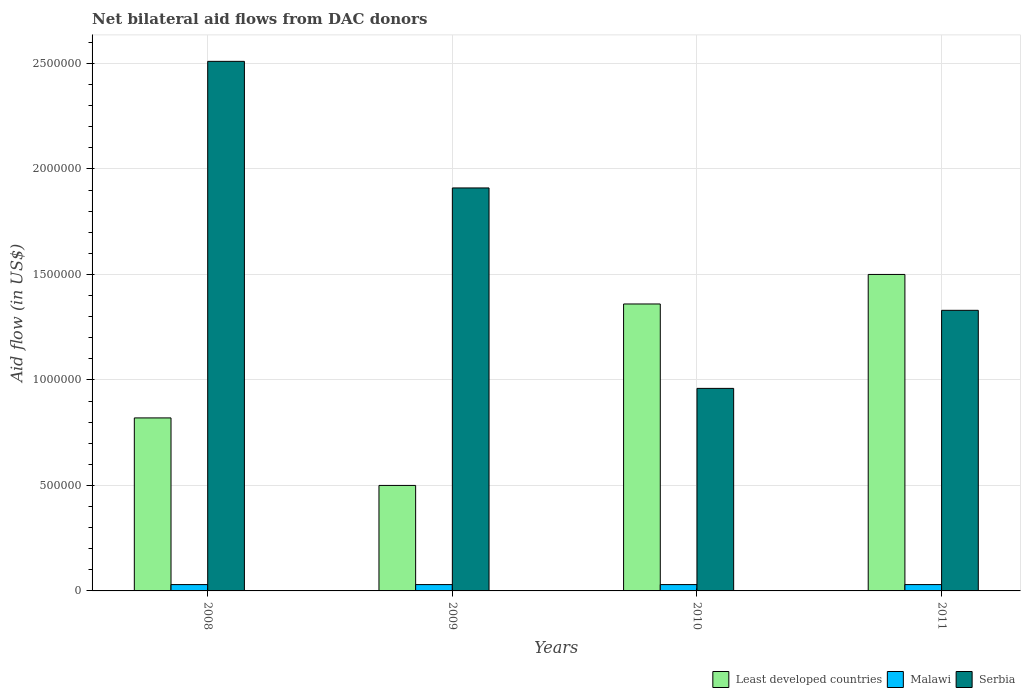How many groups of bars are there?
Provide a succinct answer. 4. Are the number of bars per tick equal to the number of legend labels?
Your answer should be very brief. Yes. How many bars are there on the 3rd tick from the left?
Offer a very short reply. 3. How many bars are there on the 4th tick from the right?
Your answer should be very brief. 3. What is the net bilateral aid flow in Least developed countries in 2009?
Your answer should be very brief. 5.00e+05. Across all years, what is the maximum net bilateral aid flow in Serbia?
Ensure brevity in your answer.  2.51e+06. Across all years, what is the minimum net bilateral aid flow in Serbia?
Make the answer very short. 9.60e+05. What is the total net bilateral aid flow in Serbia in the graph?
Offer a very short reply. 6.71e+06. What is the difference between the net bilateral aid flow in Least developed countries in 2008 and that in 2009?
Give a very brief answer. 3.20e+05. What is the difference between the net bilateral aid flow in Serbia in 2010 and the net bilateral aid flow in Least developed countries in 2009?
Keep it short and to the point. 4.60e+05. What is the average net bilateral aid flow in Serbia per year?
Your response must be concise. 1.68e+06. In the year 2010, what is the difference between the net bilateral aid flow in Malawi and net bilateral aid flow in Serbia?
Offer a terse response. -9.30e+05. In how many years, is the net bilateral aid flow in Serbia greater than 200000 US$?
Your response must be concise. 4. What is the ratio of the net bilateral aid flow in Least developed countries in 2009 to that in 2011?
Your answer should be compact. 0.33. What is the difference between the highest and the second highest net bilateral aid flow in Least developed countries?
Provide a succinct answer. 1.40e+05. What is the difference between the highest and the lowest net bilateral aid flow in Serbia?
Make the answer very short. 1.55e+06. Is the sum of the net bilateral aid flow in Malawi in 2008 and 2009 greater than the maximum net bilateral aid flow in Serbia across all years?
Offer a terse response. No. What does the 2nd bar from the left in 2011 represents?
Give a very brief answer. Malawi. What does the 3rd bar from the right in 2010 represents?
Provide a succinct answer. Least developed countries. How many bars are there?
Keep it short and to the point. 12. Are all the bars in the graph horizontal?
Offer a very short reply. No. What is the difference between two consecutive major ticks on the Y-axis?
Make the answer very short. 5.00e+05. Does the graph contain grids?
Your response must be concise. Yes. How many legend labels are there?
Your answer should be compact. 3. What is the title of the graph?
Offer a very short reply. Net bilateral aid flows from DAC donors. Does "Romania" appear as one of the legend labels in the graph?
Your answer should be very brief. No. What is the label or title of the Y-axis?
Offer a terse response. Aid flow (in US$). What is the Aid flow (in US$) in Least developed countries in 2008?
Ensure brevity in your answer.  8.20e+05. What is the Aid flow (in US$) of Malawi in 2008?
Keep it short and to the point. 3.00e+04. What is the Aid flow (in US$) in Serbia in 2008?
Provide a succinct answer. 2.51e+06. What is the Aid flow (in US$) in Least developed countries in 2009?
Your response must be concise. 5.00e+05. What is the Aid flow (in US$) in Serbia in 2009?
Offer a terse response. 1.91e+06. What is the Aid flow (in US$) of Least developed countries in 2010?
Your answer should be very brief. 1.36e+06. What is the Aid flow (in US$) in Malawi in 2010?
Offer a terse response. 3.00e+04. What is the Aid flow (in US$) in Serbia in 2010?
Provide a succinct answer. 9.60e+05. What is the Aid flow (in US$) of Least developed countries in 2011?
Provide a short and direct response. 1.50e+06. What is the Aid flow (in US$) in Serbia in 2011?
Provide a succinct answer. 1.33e+06. Across all years, what is the maximum Aid flow (in US$) in Least developed countries?
Your response must be concise. 1.50e+06. Across all years, what is the maximum Aid flow (in US$) in Serbia?
Make the answer very short. 2.51e+06. Across all years, what is the minimum Aid flow (in US$) in Least developed countries?
Offer a terse response. 5.00e+05. Across all years, what is the minimum Aid flow (in US$) of Malawi?
Give a very brief answer. 3.00e+04. Across all years, what is the minimum Aid flow (in US$) of Serbia?
Offer a terse response. 9.60e+05. What is the total Aid flow (in US$) of Least developed countries in the graph?
Your answer should be very brief. 4.18e+06. What is the total Aid flow (in US$) of Serbia in the graph?
Offer a very short reply. 6.71e+06. What is the difference between the Aid flow (in US$) of Least developed countries in 2008 and that in 2009?
Offer a very short reply. 3.20e+05. What is the difference between the Aid flow (in US$) of Serbia in 2008 and that in 2009?
Offer a very short reply. 6.00e+05. What is the difference between the Aid flow (in US$) in Least developed countries in 2008 and that in 2010?
Ensure brevity in your answer.  -5.40e+05. What is the difference between the Aid flow (in US$) in Serbia in 2008 and that in 2010?
Ensure brevity in your answer.  1.55e+06. What is the difference between the Aid flow (in US$) in Least developed countries in 2008 and that in 2011?
Offer a very short reply. -6.80e+05. What is the difference between the Aid flow (in US$) of Malawi in 2008 and that in 2011?
Keep it short and to the point. 0. What is the difference between the Aid flow (in US$) in Serbia in 2008 and that in 2011?
Give a very brief answer. 1.18e+06. What is the difference between the Aid flow (in US$) of Least developed countries in 2009 and that in 2010?
Provide a short and direct response. -8.60e+05. What is the difference between the Aid flow (in US$) in Serbia in 2009 and that in 2010?
Provide a short and direct response. 9.50e+05. What is the difference between the Aid flow (in US$) in Least developed countries in 2009 and that in 2011?
Make the answer very short. -1.00e+06. What is the difference between the Aid flow (in US$) of Malawi in 2009 and that in 2011?
Ensure brevity in your answer.  0. What is the difference between the Aid flow (in US$) in Serbia in 2009 and that in 2011?
Keep it short and to the point. 5.80e+05. What is the difference between the Aid flow (in US$) in Least developed countries in 2010 and that in 2011?
Provide a short and direct response. -1.40e+05. What is the difference between the Aid flow (in US$) in Malawi in 2010 and that in 2011?
Your answer should be very brief. 0. What is the difference between the Aid flow (in US$) of Serbia in 2010 and that in 2011?
Your response must be concise. -3.70e+05. What is the difference between the Aid flow (in US$) of Least developed countries in 2008 and the Aid flow (in US$) of Malawi in 2009?
Ensure brevity in your answer.  7.90e+05. What is the difference between the Aid flow (in US$) of Least developed countries in 2008 and the Aid flow (in US$) of Serbia in 2009?
Provide a succinct answer. -1.09e+06. What is the difference between the Aid flow (in US$) of Malawi in 2008 and the Aid flow (in US$) of Serbia in 2009?
Keep it short and to the point. -1.88e+06. What is the difference between the Aid flow (in US$) of Least developed countries in 2008 and the Aid flow (in US$) of Malawi in 2010?
Give a very brief answer. 7.90e+05. What is the difference between the Aid flow (in US$) in Least developed countries in 2008 and the Aid flow (in US$) in Serbia in 2010?
Keep it short and to the point. -1.40e+05. What is the difference between the Aid flow (in US$) in Malawi in 2008 and the Aid flow (in US$) in Serbia in 2010?
Ensure brevity in your answer.  -9.30e+05. What is the difference between the Aid flow (in US$) in Least developed countries in 2008 and the Aid flow (in US$) in Malawi in 2011?
Your response must be concise. 7.90e+05. What is the difference between the Aid flow (in US$) in Least developed countries in 2008 and the Aid flow (in US$) in Serbia in 2011?
Ensure brevity in your answer.  -5.10e+05. What is the difference between the Aid flow (in US$) in Malawi in 2008 and the Aid flow (in US$) in Serbia in 2011?
Give a very brief answer. -1.30e+06. What is the difference between the Aid flow (in US$) in Least developed countries in 2009 and the Aid flow (in US$) in Serbia in 2010?
Give a very brief answer. -4.60e+05. What is the difference between the Aid flow (in US$) in Malawi in 2009 and the Aid flow (in US$) in Serbia in 2010?
Give a very brief answer. -9.30e+05. What is the difference between the Aid flow (in US$) in Least developed countries in 2009 and the Aid flow (in US$) in Serbia in 2011?
Offer a terse response. -8.30e+05. What is the difference between the Aid flow (in US$) in Malawi in 2009 and the Aid flow (in US$) in Serbia in 2011?
Ensure brevity in your answer.  -1.30e+06. What is the difference between the Aid flow (in US$) of Least developed countries in 2010 and the Aid flow (in US$) of Malawi in 2011?
Provide a succinct answer. 1.33e+06. What is the difference between the Aid flow (in US$) in Least developed countries in 2010 and the Aid flow (in US$) in Serbia in 2011?
Provide a succinct answer. 3.00e+04. What is the difference between the Aid flow (in US$) of Malawi in 2010 and the Aid flow (in US$) of Serbia in 2011?
Give a very brief answer. -1.30e+06. What is the average Aid flow (in US$) in Least developed countries per year?
Offer a very short reply. 1.04e+06. What is the average Aid flow (in US$) of Malawi per year?
Your answer should be compact. 3.00e+04. What is the average Aid flow (in US$) in Serbia per year?
Offer a terse response. 1.68e+06. In the year 2008, what is the difference between the Aid flow (in US$) of Least developed countries and Aid flow (in US$) of Malawi?
Your answer should be compact. 7.90e+05. In the year 2008, what is the difference between the Aid flow (in US$) of Least developed countries and Aid flow (in US$) of Serbia?
Provide a succinct answer. -1.69e+06. In the year 2008, what is the difference between the Aid flow (in US$) of Malawi and Aid flow (in US$) of Serbia?
Keep it short and to the point. -2.48e+06. In the year 2009, what is the difference between the Aid flow (in US$) in Least developed countries and Aid flow (in US$) in Malawi?
Your answer should be very brief. 4.70e+05. In the year 2009, what is the difference between the Aid flow (in US$) of Least developed countries and Aid flow (in US$) of Serbia?
Your response must be concise. -1.41e+06. In the year 2009, what is the difference between the Aid flow (in US$) in Malawi and Aid flow (in US$) in Serbia?
Provide a succinct answer. -1.88e+06. In the year 2010, what is the difference between the Aid flow (in US$) of Least developed countries and Aid flow (in US$) of Malawi?
Offer a very short reply. 1.33e+06. In the year 2010, what is the difference between the Aid flow (in US$) of Malawi and Aid flow (in US$) of Serbia?
Provide a short and direct response. -9.30e+05. In the year 2011, what is the difference between the Aid flow (in US$) in Least developed countries and Aid flow (in US$) in Malawi?
Offer a terse response. 1.47e+06. In the year 2011, what is the difference between the Aid flow (in US$) of Malawi and Aid flow (in US$) of Serbia?
Provide a succinct answer. -1.30e+06. What is the ratio of the Aid flow (in US$) in Least developed countries in 2008 to that in 2009?
Make the answer very short. 1.64. What is the ratio of the Aid flow (in US$) in Serbia in 2008 to that in 2009?
Your answer should be compact. 1.31. What is the ratio of the Aid flow (in US$) in Least developed countries in 2008 to that in 2010?
Ensure brevity in your answer.  0.6. What is the ratio of the Aid flow (in US$) in Malawi in 2008 to that in 2010?
Make the answer very short. 1. What is the ratio of the Aid flow (in US$) of Serbia in 2008 to that in 2010?
Provide a short and direct response. 2.61. What is the ratio of the Aid flow (in US$) of Least developed countries in 2008 to that in 2011?
Your response must be concise. 0.55. What is the ratio of the Aid flow (in US$) of Malawi in 2008 to that in 2011?
Provide a short and direct response. 1. What is the ratio of the Aid flow (in US$) of Serbia in 2008 to that in 2011?
Ensure brevity in your answer.  1.89. What is the ratio of the Aid flow (in US$) of Least developed countries in 2009 to that in 2010?
Provide a succinct answer. 0.37. What is the ratio of the Aid flow (in US$) in Malawi in 2009 to that in 2010?
Make the answer very short. 1. What is the ratio of the Aid flow (in US$) in Serbia in 2009 to that in 2010?
Ensure brevity in your answer.  1.99. What is the ratio of the Aid flow (in US$) of Malawi in 2009 to that in 2011?
Keep it short and to the point. 1. What is the ratio of the Aid flow (in US$) in Serbia in 2009 to that in 2011?
Ensure brevity in your answer.  1.44. What is the ratio of the Aid flow (in US$) of Least developed countries in 2010 to that in 2011?
Provide a succinct answer. 0.91. What is the ratio of the Aid flow (in US$) in Serbia in 2010 to that in 2011?
Your answer should be compact. 0.72. What is the difference between the highest and the second highest Aid flow (in US$) in Least developed countries?
Your answer should be very brief. 1.40e+05. What is the difference between the highest and the second highest Aid flow (in US$) of Serbia?
Keep it short and to the point. 6.00e+05. What is the difference between the highest and the lowest Aid flow (in US$) of Serbia?
Offer a very short reply. 1.55e+06. 